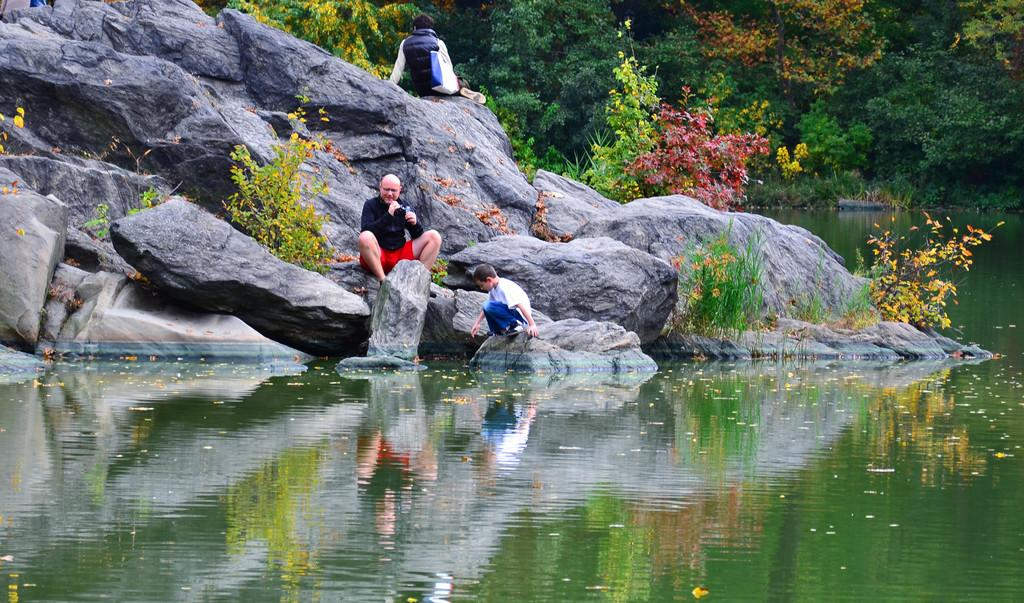What are the people in the image doing? The people in the image are sitting on rocks. What type of vegetation can be seen in the image? There are plants and trees in the image. What natural element is visible in the image? There is water visible in the image. Can you see any airplanes taking off from the airport in the image? There is no airport or airplanes present in the image. What type of bubble can be seen in the image? There are no bubbles present in the image. 